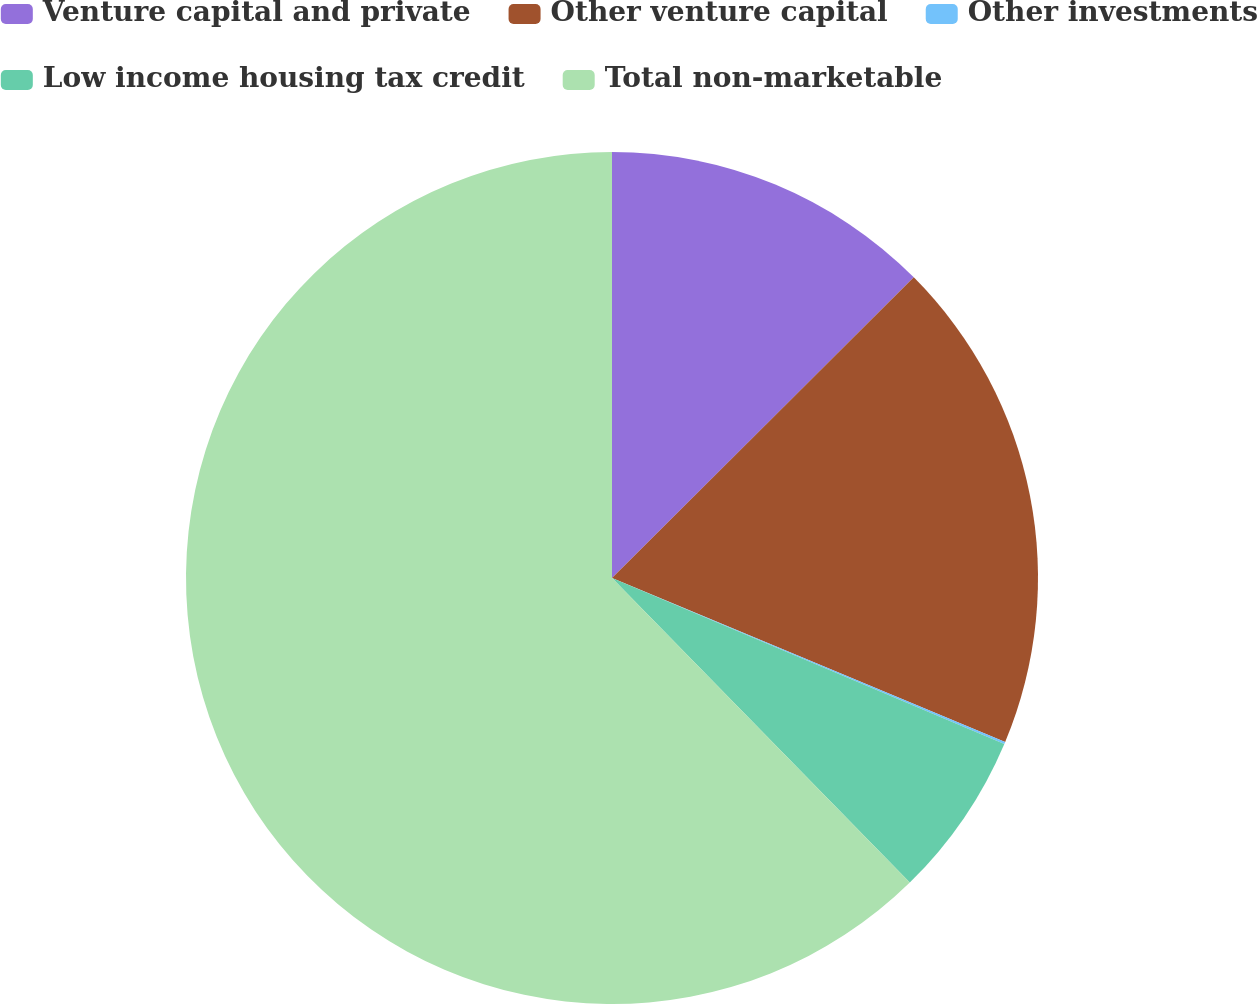Convert chart. <chart><loc_0><loc_0><loc_500><loc_500><pie_chart><fcel>Venture capital and private<fcel>Other venture capital<fcel>Other investments<fcel>Low income housing tax credit<fcel>Total non-marketable<nl><fcel>12.53%<fcel>18.76%<fcel>0.08%<fcel>6.31%<fcel>62.32%<nl></chart> 